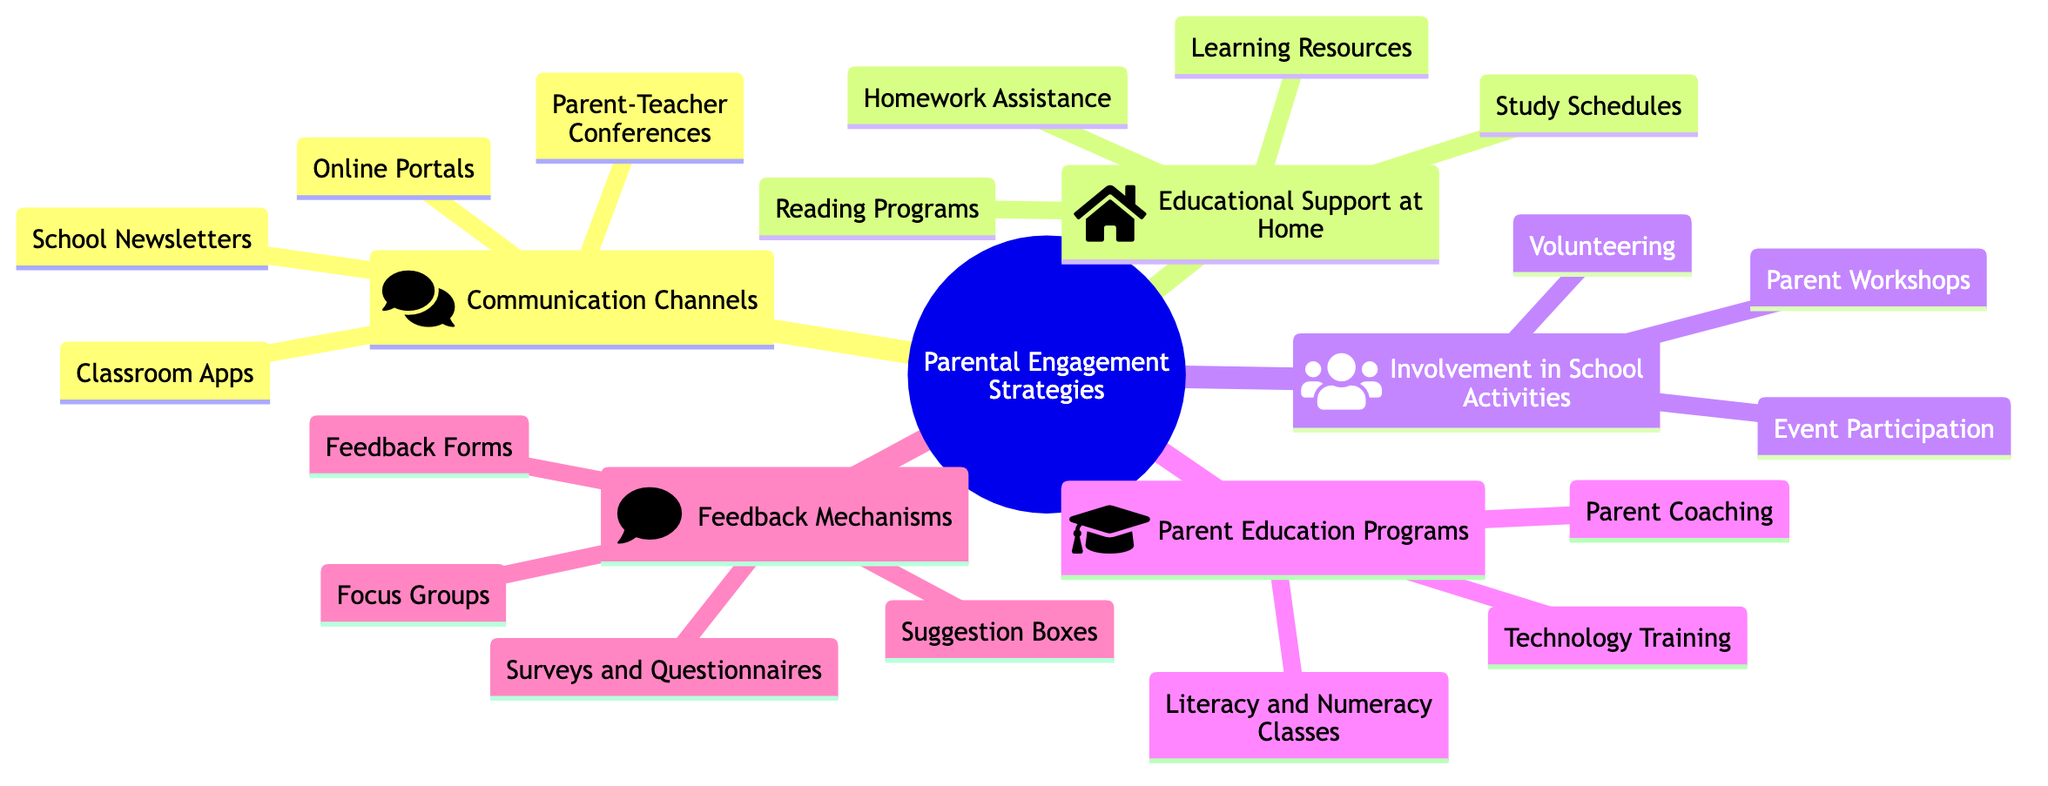What are the main categories of parental engagement strategies? The diagram has five main categories branching from the root node: Communication Channels, Educational Support at Home, Involvement in School Activities, Parent Education Programs, and Feedback Mechanisms.
Answer: Communication Channels, Educational Support at Home, Involvement in School Activities, Parent Education Programs, Feedback Mechanisms How many nodes are under the "Involvement in School Activities" category? Under the "Involvement in School Activities" category, there are three nodes: Volunteering, Parent Workshops, and Event Participation, totaling three nodes.
Answer: 3 What is the purpose of "Parent-Teacher Conferences"? The description of "Parent-Teacher Conferences" states that it is for regularly scheduled meetings for discussing student progress, which highlights its purpose clearly.
Answer: Regularly scheduled meetings for discussing student progress Which category contains "Parent Coaching"? "Parent Coaching" is located under the category of "Parent Education Programs," as can be seen by tracing the node from the root to its respective category.
Answer: Parent Education Programs What type of student support is suggested by "Study Schedules"? The node "Study Schedules" provides recommendations for setting up a productive study routine, indicating its focus on organizing study time effectively for students.
Answer: Recommendations for setting up a productive study routine Which communication method allows immediate updates? "Classroom Apps" is explicitly described as providing immediate updates and communication, making it the method for quick interactions between parents and teachers.
Answer: Classroom Apps How many feedback mechanisms are listed in the diagram? The diagram lists four feedback mechanisms: Surveys and Questionnaires, Feedback Forms, Suggestion Boxes, and Focus Groups, resulting in a total count of four mechanisms.
Answer: 4 What opportunity does "Volunteering" offer parents? "Volunteering" mentions opportunities for parents to assist in school events and functions, highlighting how parents can engage directly with the school community.
Answer: Opportunities for parents to assist in school events and functions What educational support does "Learning Resources" provide? "Learning Resources" informs about providing access to educational websites and libraries, indicating the type of support it offers to enhance student learning at home.
Answer: Providing access to educational websites and libraries 